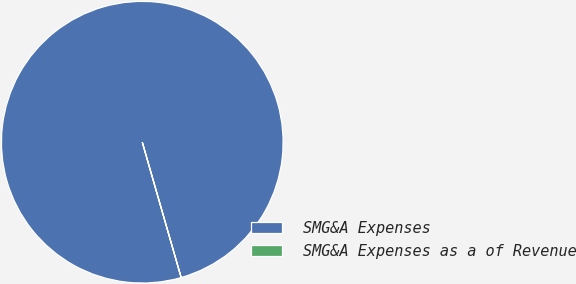<chart> <loc_0><loc_0><loc_500><loc_500><pie_chart><fcel>SMG&A Expenses<fcel>SMG&A Expenses as a of Revenue<nl><fcel>100.0%<fcel>0.0%<nl></chart> 